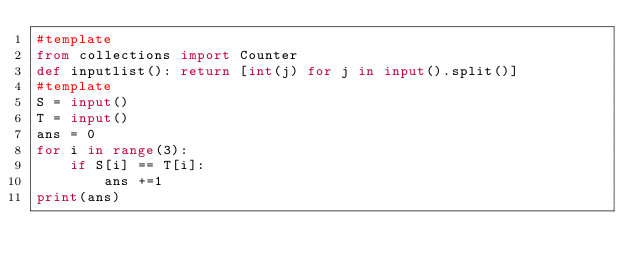<code> <loc_0><loc_0><loc_500><loc_500><_Python_>#template
from collections import Counter
def inputlist(): return [int(j) for j in input().split()]
#template
S = input()
T = input()
ans = 0
for i in range(3):
    if S[i] == T[i]:
        ans +=1
print(ans)</code> 